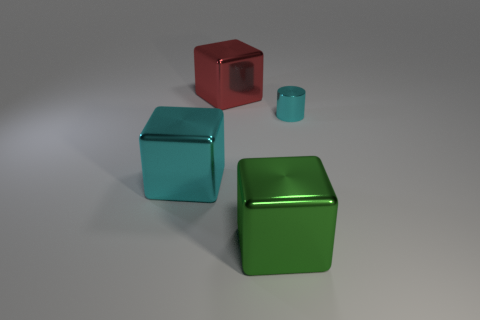Can we ascertain the time of day or type of environment this image represents? This image appears to be a studio setup with controlled lighting rather than a depiction of a natural environment, making it difficult to infer a specific time of day. 